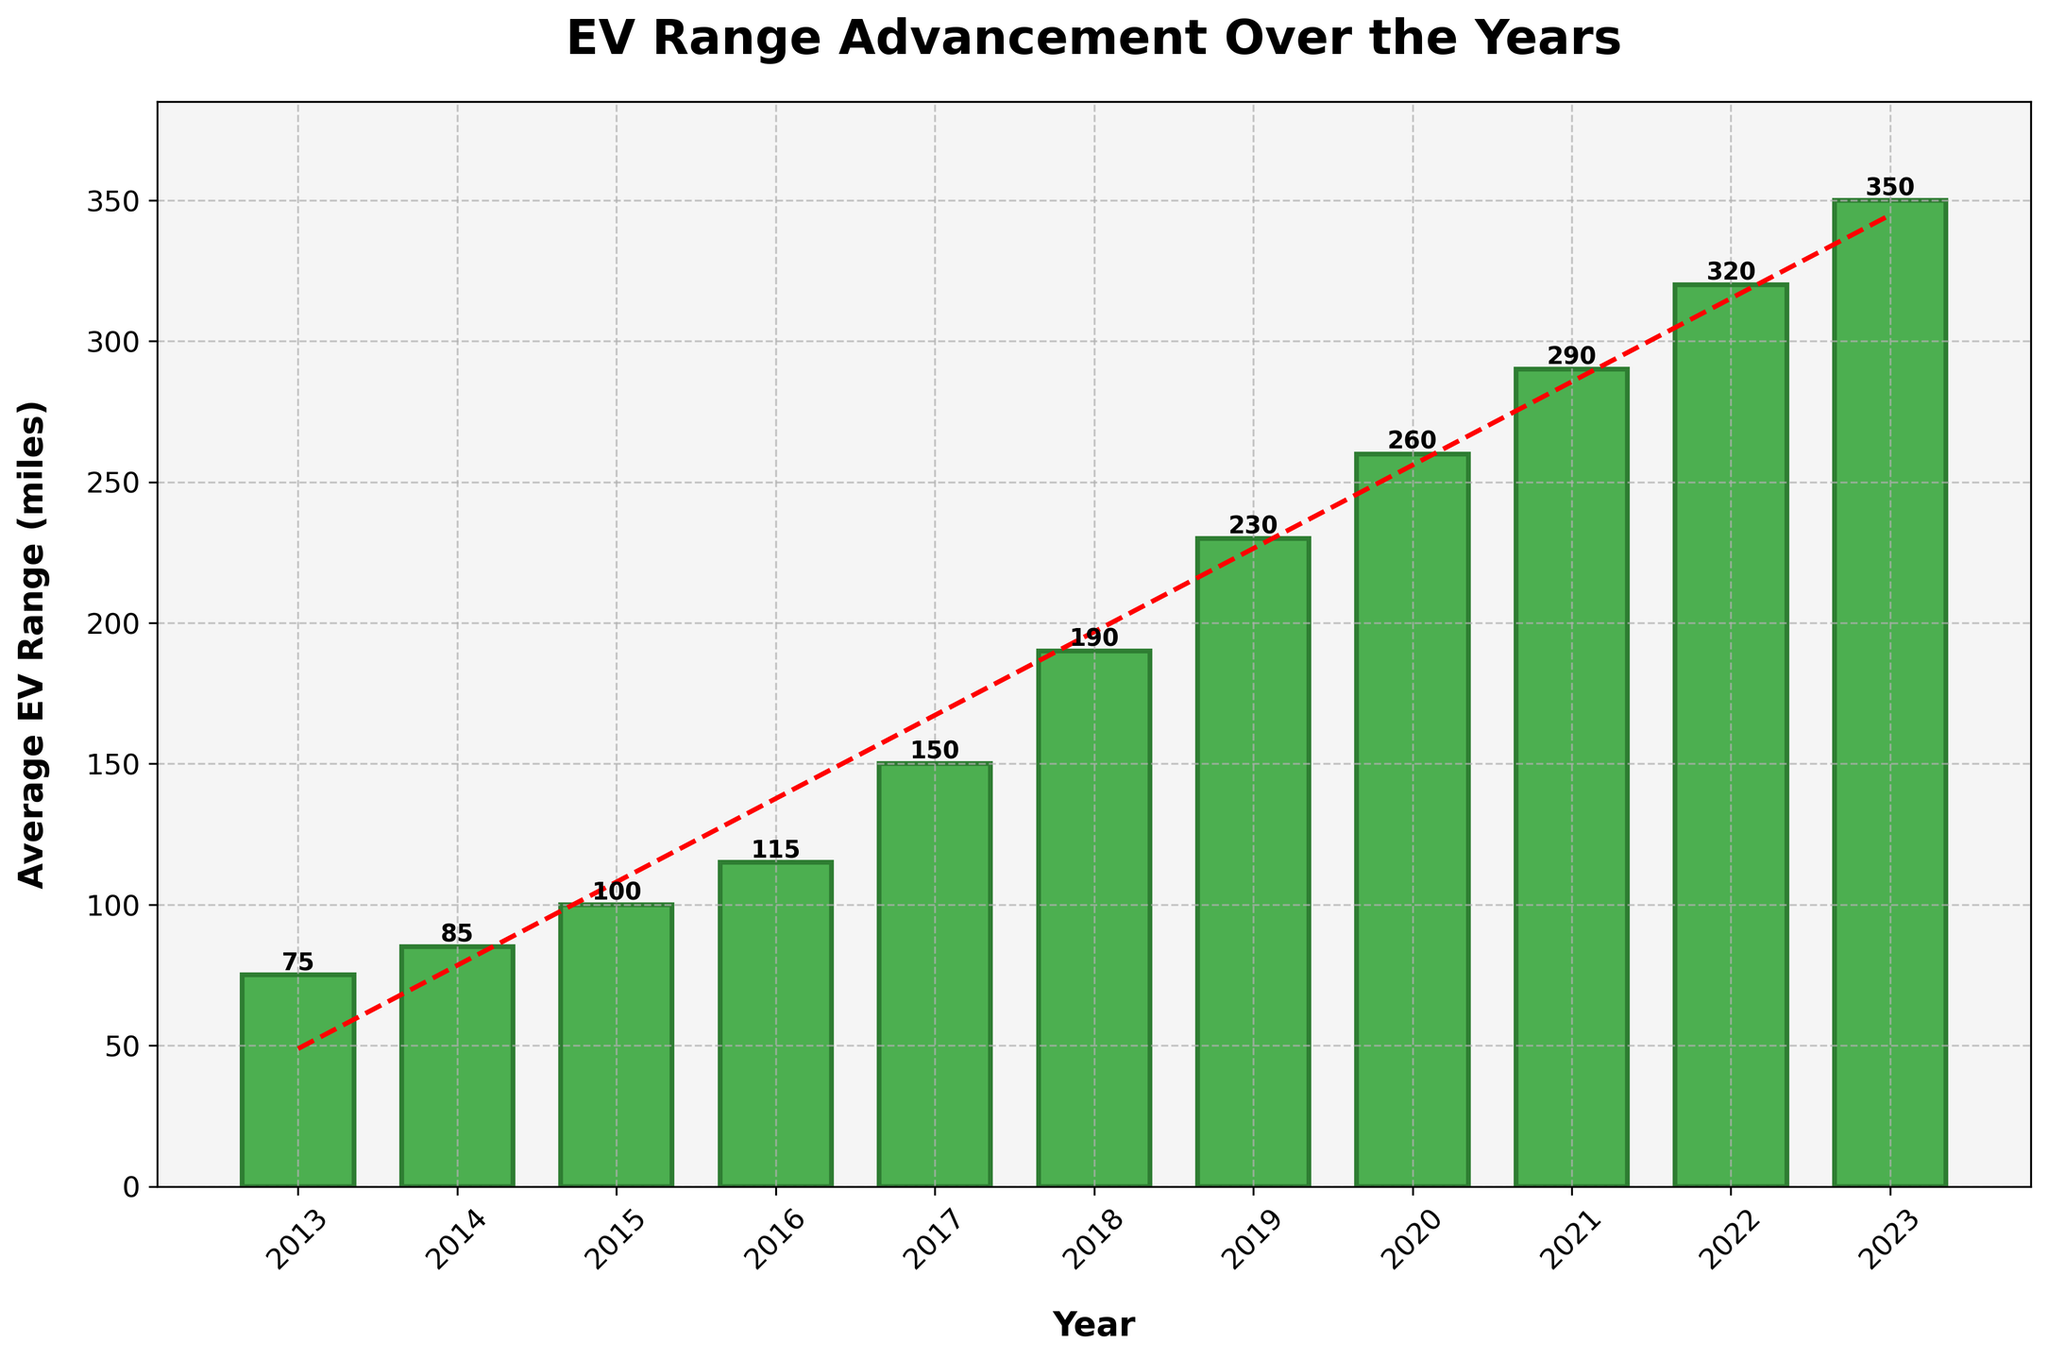Which year saw the most significant increase in average EV range? Compare the differences in average EV range between consecutive years. The largest increase occurred between 2016 (115 miles) and 2017 (150 miles), which is an increase of 35 miles.
Answer: 2017 How many years took for the average EV range to exceed 200 miles? Identify the year when the average EV range first exceeded 200 miles (2019) and count the years from the beginning of the dataset (2013) to that year. It took 7 years (2013 to 2019).
Answer: 7 years What is the average annual increase in EV range over the decade? Calculate the difference in EV range from 2023 (350 miles) to 2013 (75 miles) which is 275 miles. Divide this by the number of years (10). 275/10 = 27.5 miles per year.
Answer: 27.5 miles per year Compare the average EV range in 2015 to that in 2018. Which is higher, and by how much? Check the average EV range for 2015 (100 miles) and 2018 (190 miles). The value in 2018 is higher by 190 - 100 = 90 miles.
Answer: 2018 by 90 miles What is the total increase in average EV range from 2013 to 2023? Subtract the average EV range in 2013 (75 miles) from that in 2023 (350 miles). 350 - 75 = 275 miles.
Answer: 275 miles Which year had a higher average EV range: 2016 or 2017? Compare the values for 2016 (115 miles) and 2017 (150 miles). 2017 had a higher average EV range.
Answer: 2017 What is the combined average EV range for the first five years (2013 to 2017)? Sum the ranges for the years 2013 to 2017: 75 + 85 + 100 + 115 + 150 = 525 miles.
Answer: 525 miles If the trend continues, what would be the expected average EV range for the year 2024? Extend the trend line (red dashed line) from 2023 (350 miles) to 2024 using its slope. Visual estimation suggests an approximate value around 380 miles considering an annual increase.
Answer: ~380 miles Is the rate of increase in average EV range consistent throughout the decade? Examine the trend line and bar height differences between consecutive years. The rate accelerates especially after 2016, indicating an increasing rate rather than a consistent one.
Answer: No, it accelerates What visual feature indicates the addition of a trend line in the chart? Identify the red dashed line running through the middle of the bars, showing the general trend.
Answer: Red dashed line 